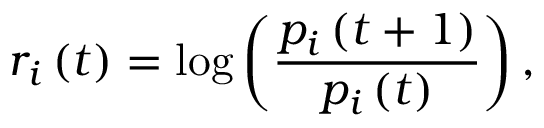Convert formula to latex. <formula><loc_0><loc_0><loc_500><loc_500>r _ { i } \left ( t \right ) = \log \left ( \frac { p _ { i } \left ( t + 1 \right ) } { p _ { i } \left ( t \right ) } \right ) ,</formula> 